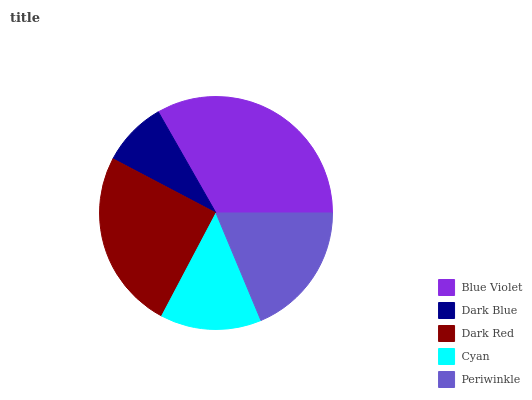Is Dark Blue the minimum?
Answer yes or no. Yes. Is Blue Violet the maximum?
Answer yes or no. Yes. Is Dark Red the minimum?
Answer yes or no. No. Is Dark Red the maximum?
Answer yes or no. No. Is Dark Red greater than Dark Blue?
Answer yes or no. Yes. Is Dark Blue less than Dark Red?
Answer yes or no. Yes. Is Dark Blue greater than Dark Red?
Answer yes or no. No. Is Dark Red less than Dark Blue?
Answer yes or no. No. Is Periwinkle the high median?
Answer yes or no. Yes. Is Periwinkle the low median?
Answer yes or no. Yes. Is Blue Violet the high median?
Answer yes or no. No. Is Dark Red the low median?
Answer yes or no. No. 